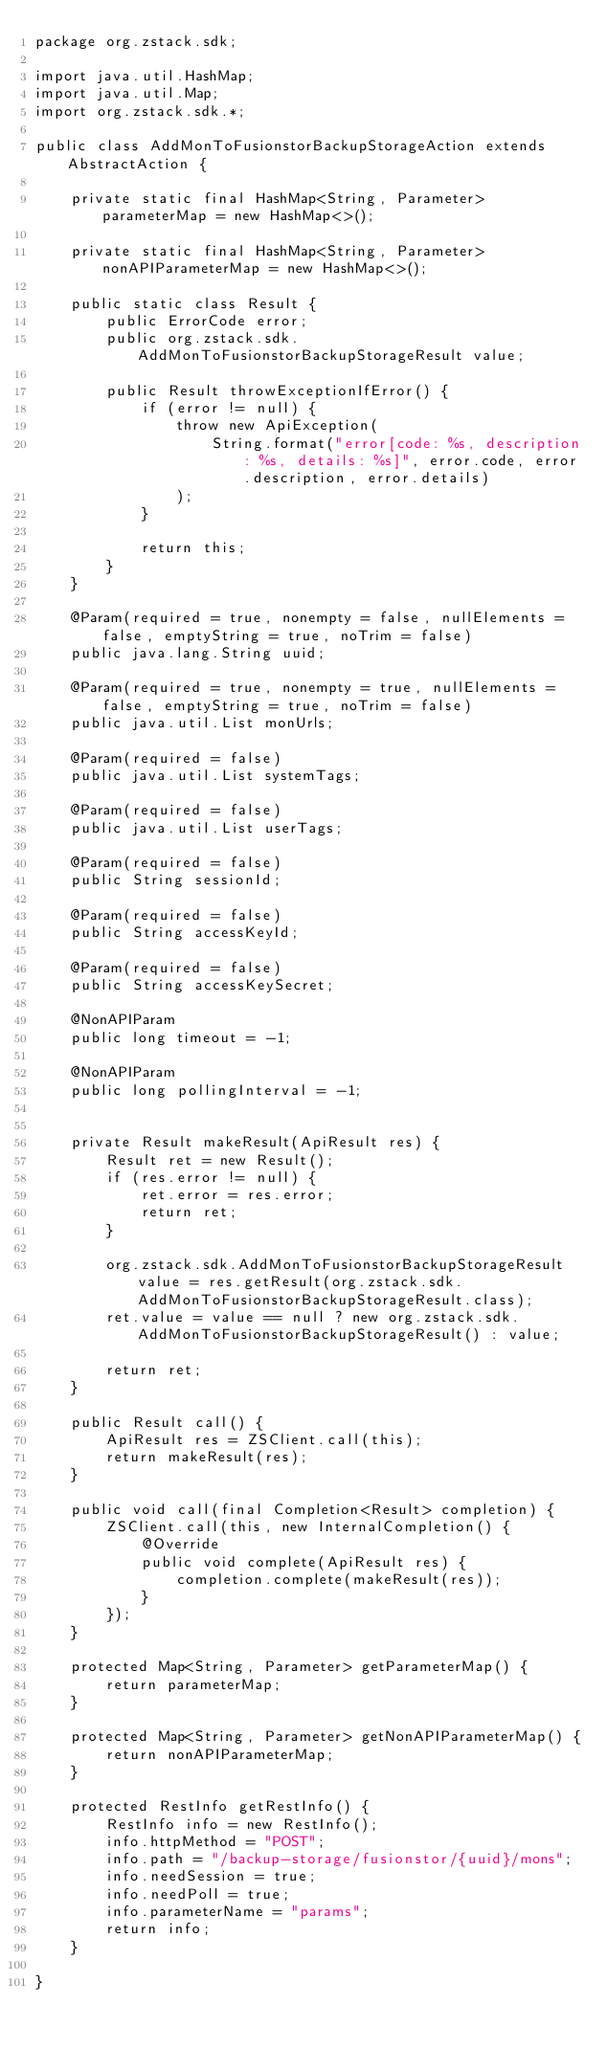<code> <loc_0><loc_0><loc_500><loc_500><_Java_>package org.zstack.sdk;

import java.util.HashMap;
import java.util.Map;
import org.zstack.sdk.*;

public class AddMonToFusionstorBackupStorageAction extends AbstractAction {

    private static final HashMap<String, Parameter> parameterMap = new HashMap<>();

    private static final HashMap<String, Parameter> nonAPIParameterMap = new HashMap<>();

    public static class Result {
        public ErrorCode error;
        public org.zstack.sdk.AddMonToFusionstorBackupStorageResult value;

        public Result throwExceptionIfError() {
            if (error != null) {
                throw new ApiException(
                    String.format("error[code: %s, description: %s, details: %s]", error.code, error.description, error.details)
                );
            }
            
            return this;
        }
    }

    @Param(required = true, nonempty = false, nullElements = false, emptyString = true, noTrim = false)
    public java.lang.String uuid;

    @Param(required = true, nonempty = true, nullElements = false, emptyString = true, noTrim = false)
    public java.util.List monUrls;

    @Param(required = false)
    public java.util.List systemTags;

    @Param(required = false)
    public java.util.List userTags;

    @Param(required = false)
    public String sessionId;

    @Param(required = false)
    public String accessKeyId;

    @Param(required = false)
    public String accessKeySecret;

    @NonAPIParam
    public long timeout = -1;

    @NonAPIParam
    public long pollingInterval = -1;


    private Result makeResult(ApiResult res) {
        Result ret = new Result();
        if (res.error != null) {
            ret.error = res.error;
            return ret;
        }
        
        org.zstack.sdk.AddMonToFusionstorBackupStorageResult value = res.getResult(org.zstack.sdk.AddMonToFusionstorBackupStorageResult.class);
        ret.value = value == null ? new org.zstack.sdk.AddMonToFusionstorBackupStorageResult() : value; 

        return ret;
    }

    public Result call() {
        ApiResult res = ZSClient.call(this);
        return makeResult(res);
    }

    public void call(final Completion<Result> completion) {
        ZSClient.call(this, new InternalCompletion() {
            @Override
            public void complete(ApiResult res) {
                completion.complete(makeResult(res));
            }
        });
    }

    protected Map<String, Parameter> getParameterMap() {
        return parameterMap;
    }

    protected Map<String, Parameter> getNonAPIParameterMap() {
        return nonAPIParameterMap;
    }

    protected RestInfo getRestInfo() {
        RestInfo info = new RestInfo();
        info.httpMethod = "POST";
        info.path = "/backup-storage/fusionstor/{uuid}/mons";
        info.needSession = true;
        info.needPoll = true;
        info.parameterName = "params";
        return info;
    }

}
</code> 